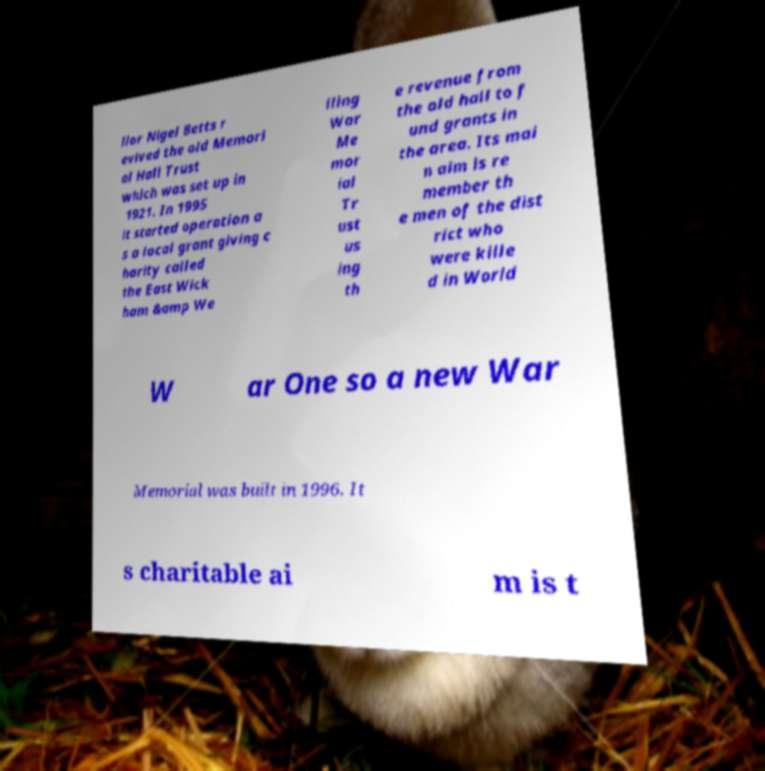Could you extract and type out the text from this image? llor Nigel Betts r evived the old Memori al Hall Trust which was set up in 1921. In 1995 it started operation a s a local grant giving c harity called the East Wick ham &amp We lling War Me mor ial Tr ust us ing th e revenue from the old hall to f und grants in the area. Its mai n aim is re member th e men of the dist rict who were kille d in World W ar One so a new War Memorial was built in 1996. It s charitable ai m is t 